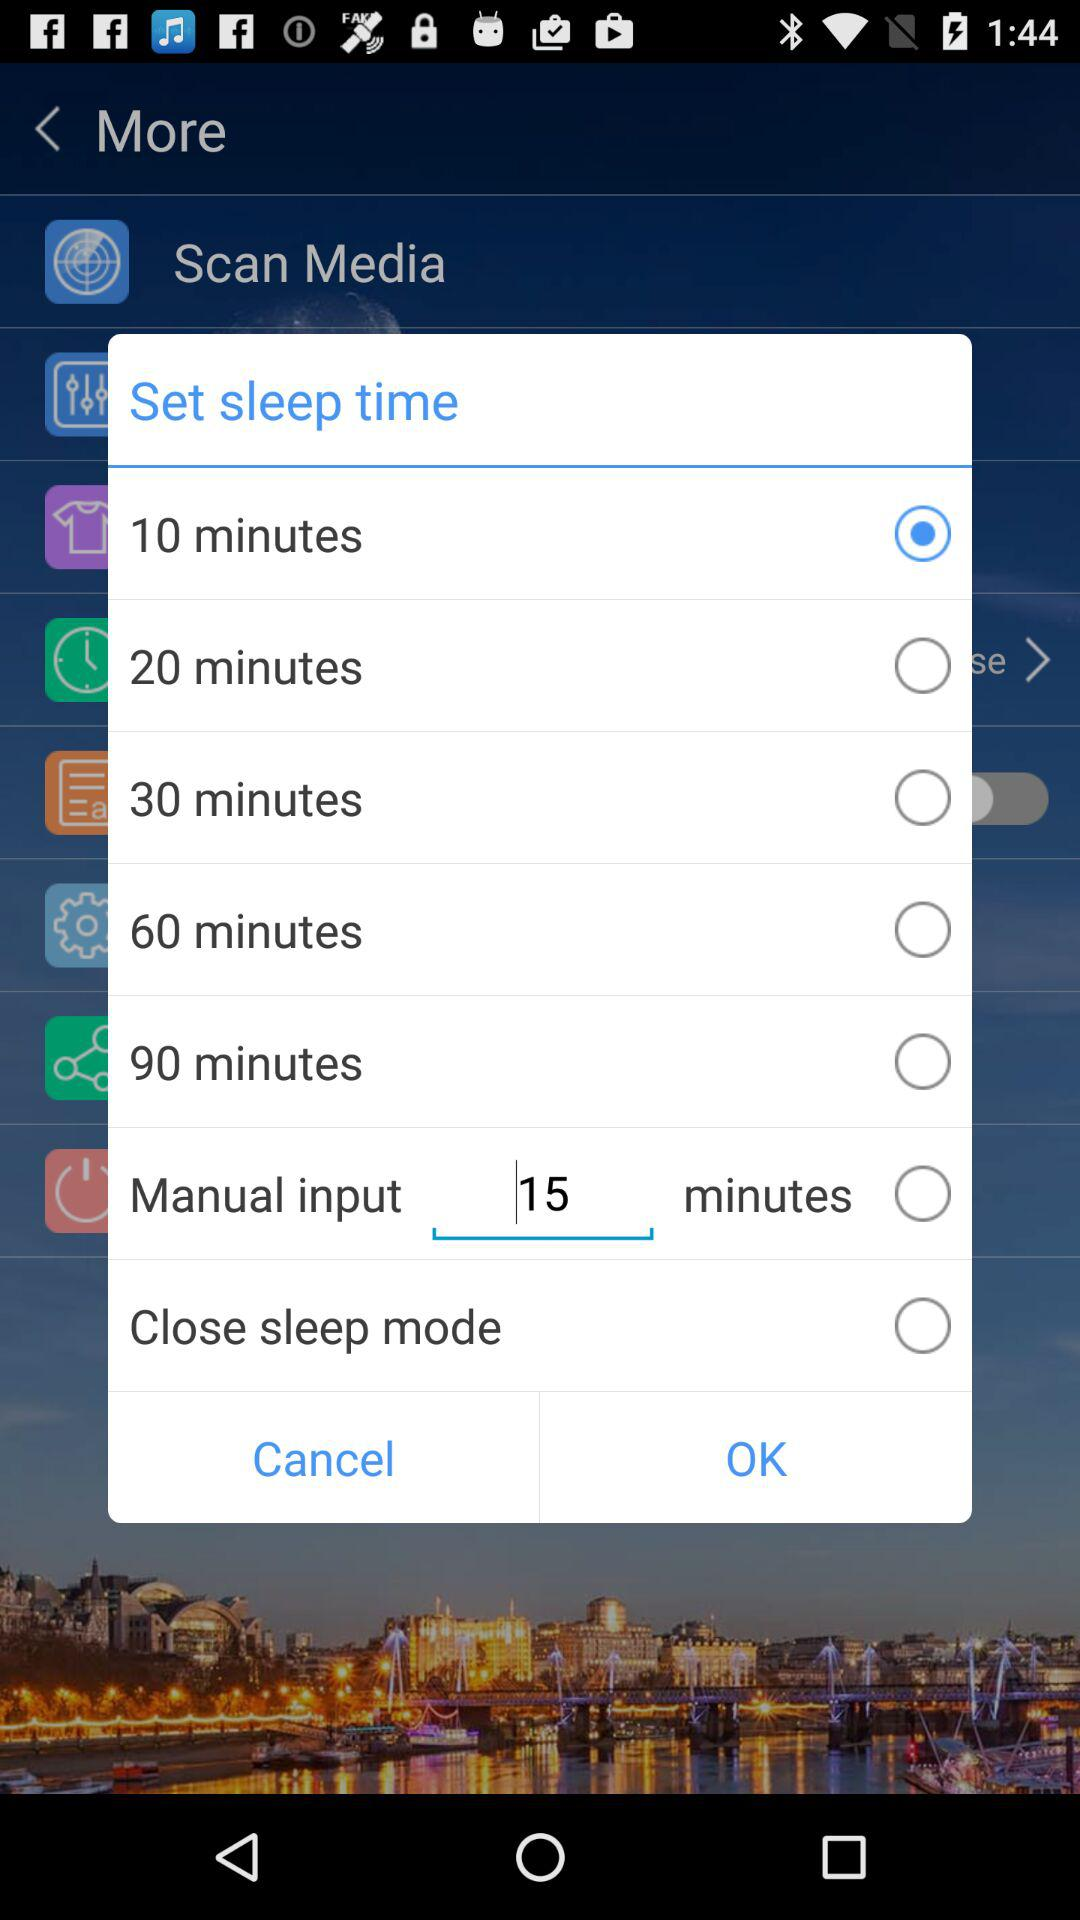What is the current status of "Close sleep mode"? The current status is "off". 